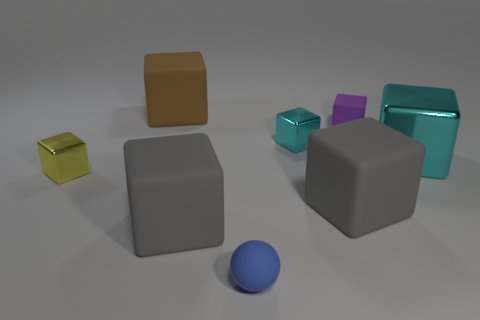Subtract all cyan blocks. How many blocks are left? 5 Subtract all cyan cubes. How many cubes are left? 5 Subtract all cyan cubes. Subtract all brown spheres. How many cubes are left? 5 Add 1 small cyan things. How many objects exist? 9 Subtract all balls. How many objects are left? 7 Subtract all big purple metal cylinders. Subtract all metallic cubes. How many objects are left? 5 Add 7 brown matte cubes. How many brown matte cubes are left? 8 Add 3 tiny purple objects. How many tiny purple objects exist? 4 Subtract 0 red cylinders. How many objects are left? 8 